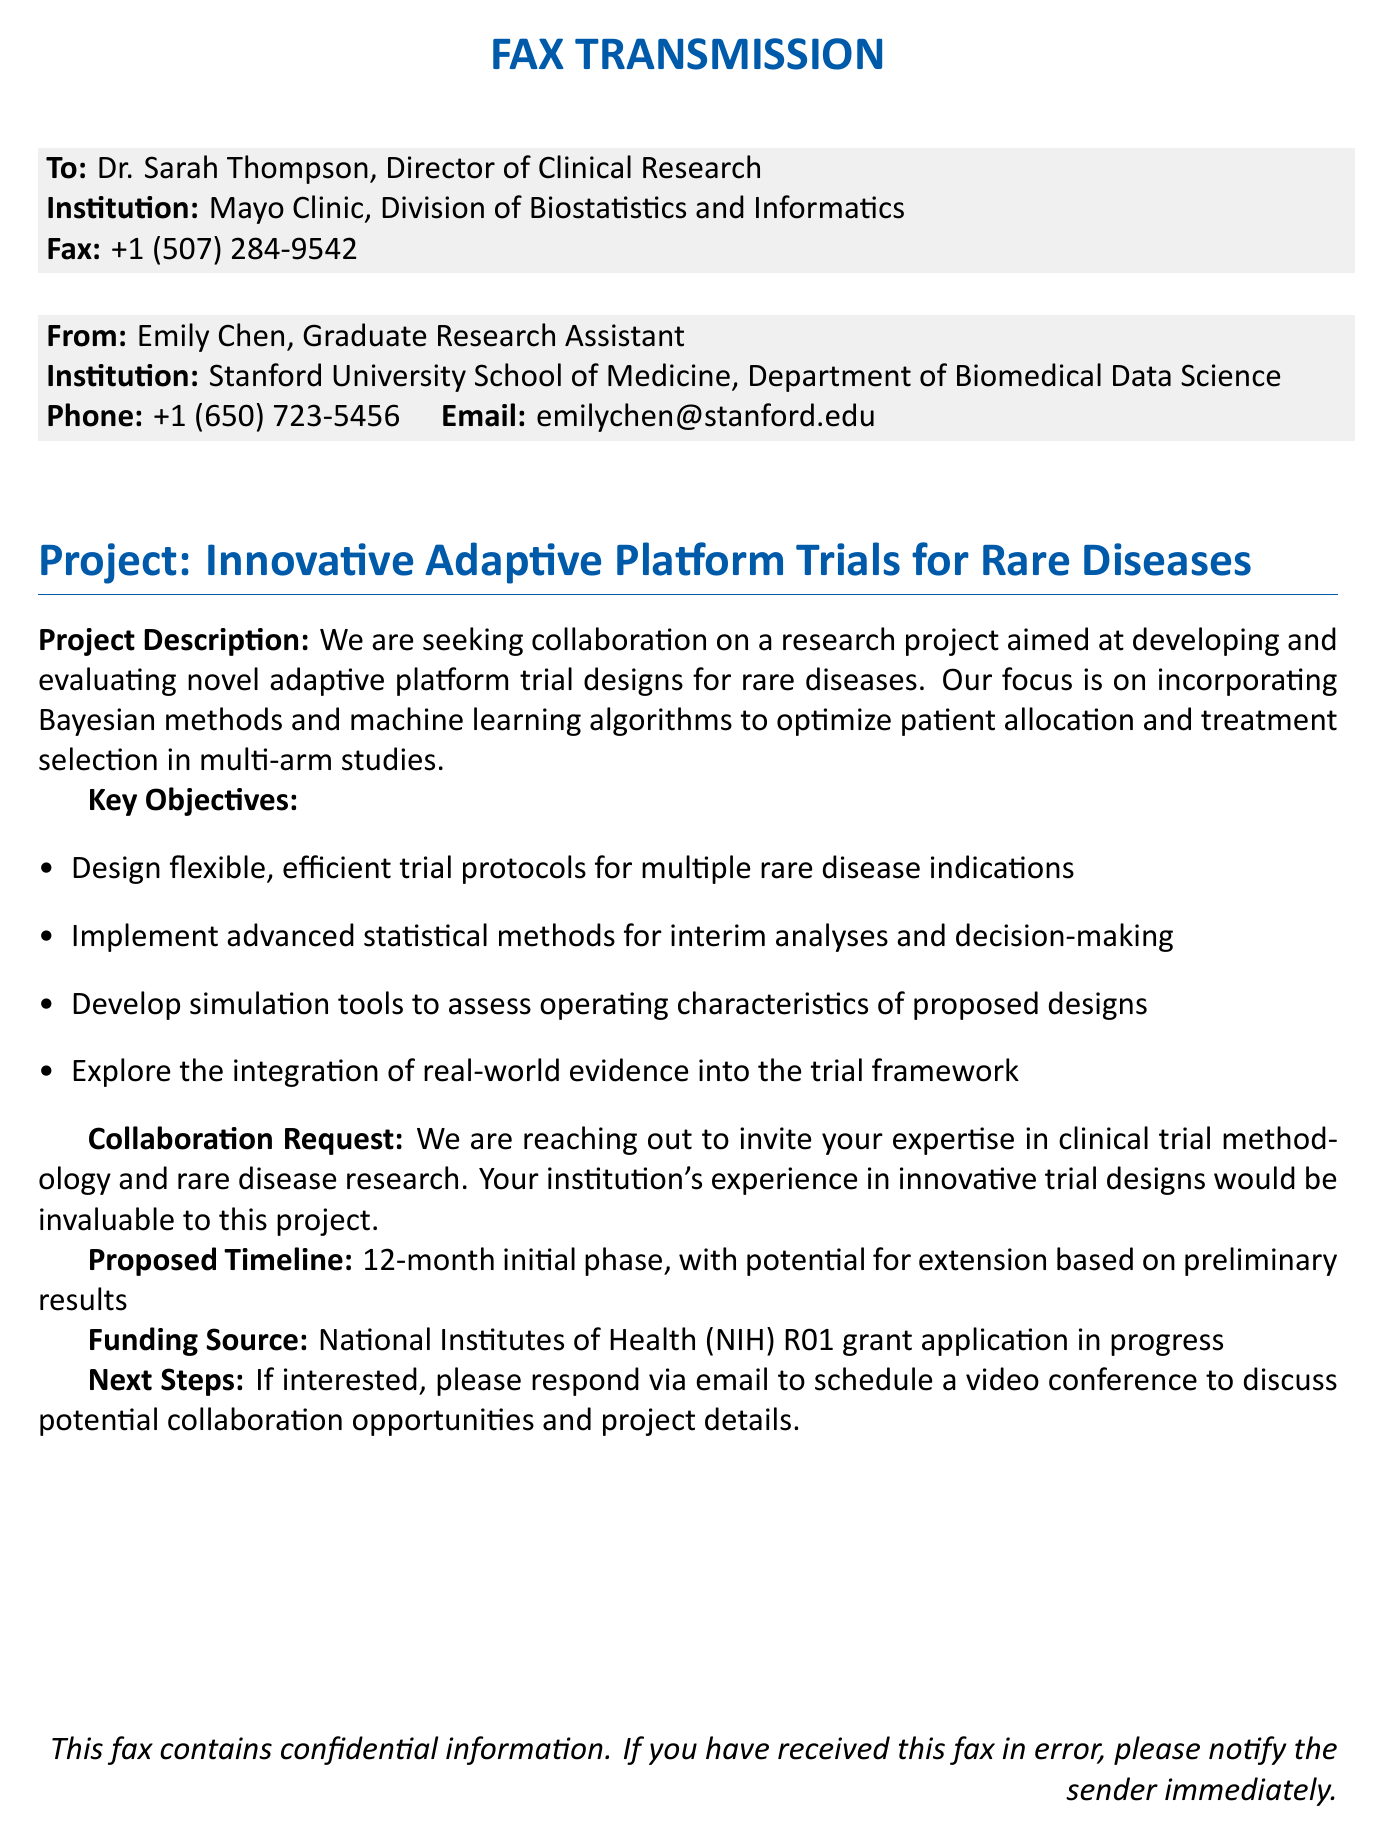What is the name of the project? The project's title is explicitly stated in the document under the section header.
Answer: Innovative Adaptive Platform Trials for Rare Diseases Who is the sender of this fax? The sender's name and role are mentioned at the beginning of the document.
Answer: Emily Chen What is the contact email provided? The email address is listed under the sender's information.
Answer: emilychen@stanford.edu What is the proposed timeline for the project? The timeline for the initial phase is specified in the project description.
Answer: 12-month initial phase What funding source is mentioned for the project? The funding source is indicated toward the end of the document.
Answer: National Institutes of Health (NIH) What statistical methods are emphasized in the project? The document lists key objectives, which include specific methods aimed at optimizing the trial design.
Answer: Bayesian methods and machine learning algorithms What institution is Dr. Sarah Thompson affiliated with? The institution is mentioned directly under the recipient's information in the fax.
Answer: Mayo Clinic, Division of Biostatistics and Informatics What is the main objective of the project? The primary focus is outlined in the project description in terms of trial design.
Answer: Developing and evaluating novel adaptive platform trial designs What should interested collaborators do next? The next steps for engagement are clearly mentioned in the collaboration request section.
Answer: Respond via email to schedule a video conference 